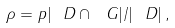Convert formula to latex. <formula><loc_0><loc_0><loc_500><loc_500>\rho = p | \ D \cap \ G | / | \ D | \, ,</formula> 